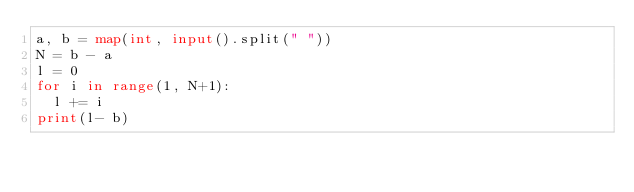<code> <loc_0><loc_0><loc_500><loc_500><_Python_>a, b = map(int, input().split(" "))
N = b - a
l = 0
for i in range(1, N+1):
  l += i
print(l- b)</code> 